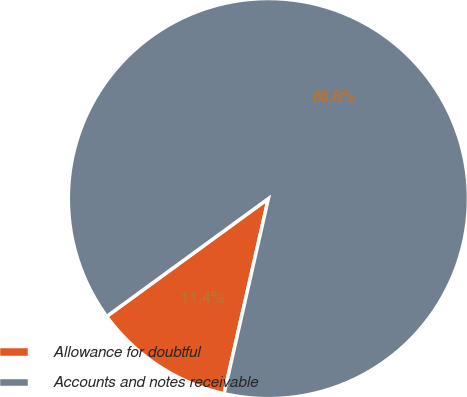Convert chart to OTSL. <chart><loc_0><loc_0><loc_500><loc_500><pie_chart><fcel>Allowance for doubtful<fcel>Accounts and notes receivable<nl><fcel>11.42%<fcel>88.58%<nl></chart> 